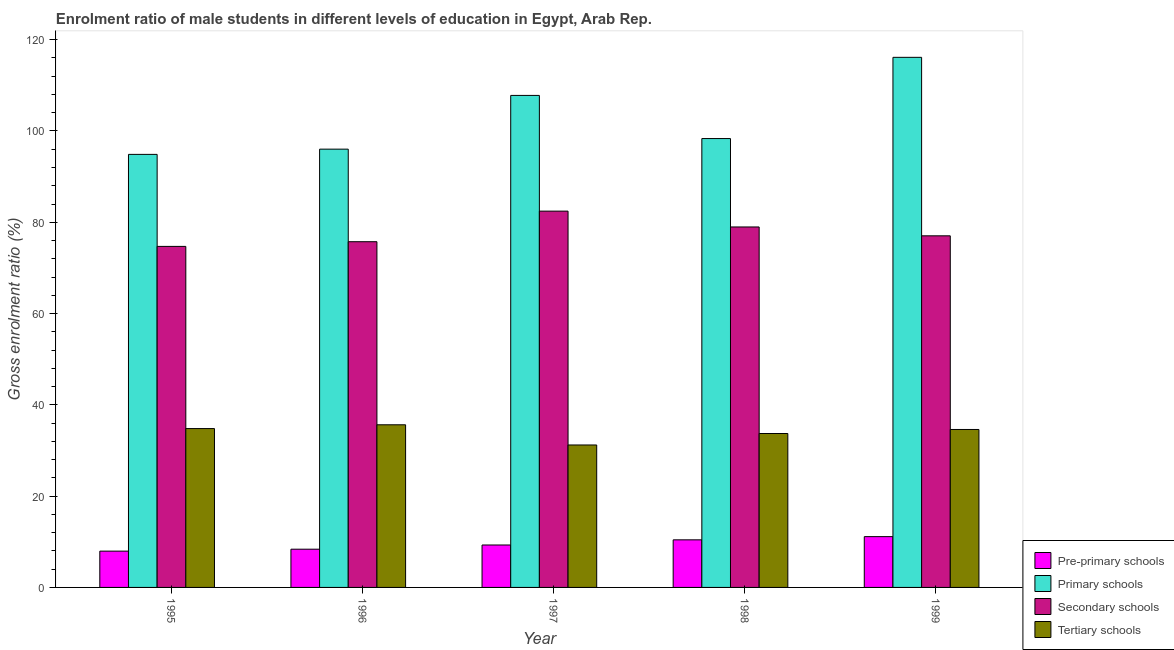How many groups of bars are there?
Provide a succinct answer. 5. Are the number of bars on each tick of the X-axis equal?
Provide a short and direct response. Yes. In how many cases, is the number of bars for a given year not equal to the number of legend labels?
Your answer should be very brief. 0. What is the gross enrolment ratio(female) in secondary schools in 1997?
Provide a succinct answer. 82.44. Across all years, what is the maximum gross enrolment ratio(female) in tertiary schools?
Make the answer very short. 35.63. Across all years, what is the minimum gross enrolment ratio(female) in primary schools?
Your answer should be very brief. 94.87. In which year was the gross enrolment ratio(female) in secondary schools minimum?
Give a very brief answer. 1995. What is the total gross enrolment ratio(female) in pre-primary schools in the graph?
Make the answer very short. 47.18. What is the difference between the gross enrolment ratio(female) in secondary schools in 1995 and that in 1997?
Offer a terse response. -7.73. What is the difference between the gross enrolment ratio(female) in secondary schools in 1998 and the gross enrolment ratio(female) in tertiary schools in 1999?
Provide a short and direct response. 1.94. What is the average gross enrolment ratio(female) in pre-primary schools per year?
Your answer should be compact. 9.44. In the year 1997, what is the difference between the gross enrolment ratio(female) in primary schools and gross enrolment ratio(female) in tertiary schools?
Give a very brief answer. 0. What is the ratio of the gross enrolment ratio(female) in pre-primary schools in 1995 to that in 1998?
Ensure brevity in your answer.  0.76. What is the difference between the highest and the second highest gross enrolment ratio(female) in secondary schools?
Give a very brief answer. 3.47. What is the difference between the highest and the lowest gross enrolment ratio(female) in secondary schools?
Provide a succinct answer. 7.73. What does the 2nd bar from the left in 1997 represents?
Keep it short and to the point. Primary schools. What does the 4th bar from the right in 1999 represents?
Ensure brevity in your answer.  Pre-primary schools. Is it the case that in every year, the sum of the gross enrolment ratio(female) in pre-primary schools and gross enrolment ratio(female) in primary schools is greater than the gross enrolment ratio(female) in secondary schools?
Provide a short and direct response. Yes. What is the difference between two consecutive major ticks on the Y-axis?
Give a very brief answer. 20. Where does the legend appear in the graph?
Provide a short and direct response. Bottom right. What is the title of the graph?
Offer a very short reply. Enrolment ratio of male students in different levels of education in Egypt, Arab Rep. What is the Gross enrolment ratio (%) in Pre-primary schools in 1995?
Provide a short and direct response. 7.95. What is the Gross enrolment ratio (%) in Primary schools in 1995?
Provide a short and direct response. 94.87. What is the Gross enrolment ratio (%) in Secondary schools in 1995?
Make the answer very short. 74.72. What is the Gross enrolment ratio (%) in Tertiary schools in 1995?
Make the answer very short. 34.8. What is the Gross enrolment ratio (%) in Pre-primary schools in 1996?
Your answer should be compact. 8.38. What is the Gross enrolment ratio (%) of Primary schools in 1996?
Provide a succinct answer. 96.02. What is the Gross enrolment ratio (%) of Secondary schools in 1996?
Make the answer very short. 75.74. What is the Gross enrolment ratio (%) in Tertiary schools in 1996?
Ensure brevity in your answer.  35.63. What is the Gross enrolment ratio (%) of Pre-primary schools in 1997?
Your response must be concise. 9.3. What is the Gross enrolment ratio (%) of Primary schools in 1997?
Make the answer very short. 107.79. What is the Gross enrolment ratio (%) in Secondary schools in 1997?
Provide a succinct answer. 82.44. What is the Gross enrolment ratio (%) of Tertiary schools in 1997?
Keep it short and to the point. 31.21. What is the Gross enrolment ratio (%) of Pre-primary schools in 1998?
Ensure brevity in your answer.  10.43. What is the Gross enrolment ratio (%) of Primary schools in 1998?
Offer a terse response. 98.34. What is the Gross enrolment ratio (%) of Secondary schools in 1998?
Your answer should be very brief. 78.97. What is the Gross enrolment ratio (%) of Tertiary schools in 1998?
Ensure brevity in your answer.  33.72. What is the Gross enrolment ratio (%) of Pre-primary schools in 1999?
Ensure brevity in your answer.  11.13. What is the Gross enrolment ratio (%) of Primary schools in 1999?
Offer a terse response. 116.14. What is the Gross enrolment ratio (%) in Secondary schools in 1999?
Provide a succinct answer. 77.03. What is the Gross enrolment ratio (%) in Tertiary schools in 1999?
Give a very brief answer. 34.6. Across all years, what is the maximum Gross enrolment ratio (%) in Pre-primary schools?
Give a very brief answer. 11.13. Across all years, what is the maximum Gross enrolment ratio (%) in Primary schools?
Keep it short and to the point. 116.14. Across all years, what is the maximum Gross enrolment ratio (%) in Secondary schools?
Offer a terse response. 82.44. Across all years, what is the maximum Gross enrolment ratio (%) of Tertiary schools?
Give a very brief answer. 35.63. Across all years, what is the minimum Gross enrolment ratio (%) in Pre-primary schools?
Your answer should be very brief. 7.95. Across all years, what is the minimum Gross enrolment ratio (%) in Primary schools?
Keep it short and to the point. 94.87. Across all years, what is the minimum Gross enrolment ratio (%) in Secondary schools?
Your answer should be very brief. 74.72. Across all years, what is the minimum Gross enrolment ratio (%) of Tertiary schools?
Offer a very short reply. 31.21. What is the total Gross enrolment ratio (%) in Pre-primary schools in the graph?
Make the answer very short. 47.18. What is the total Gross enrolment ratio (%) of Primary schools in the graph?
Keep it short and to the point. 513.17. What is the total Gross enrolment ratio (%) in Secondary schools in the graph?
Ensure brevity in your answer.  388.91. What is the total Gross enrolment ratio (%) in Tertiary schools in the graph?
Make the answer very short. 169.97. What is the difference between the Gross enrolment ratio (%) of Pre-primary schools in 1995 and that in 1996?
Provide a short and direct response. -0.42. What is the difference between the Gross enrolment ratio (%) in Primary schools in 1995 and that in 1996?
Make the answer very short. -1.15. What is the difference between the Gross enrolment ratio (%) of Secondary schools in 1995 and that in 1996?
Provide a short and direct response. -1.03. What is the difference between the Gross enrolment ratio (%) in Tertiary schools in 1995 and that in 1996?
Ensure brevity in your answer.  -0.83. What is the difference between the Gross enrolment ratio (%) of Pre-primary schools in 1995 and that in 1997?
Your response must be concise. -1.34. What is the difference between the Gross enrolment ratio (%) of Primary schools in 1995 and that in 1997?
Ensure brevity in your answer.  -12.92. What is the difference between the Gross enrolment ratio (%) in Secondary schools in 1995 and that in 1997?
Provide a succinct answer. -7.73. What is the difference between the Gross enrolment ratio (%) in Tertiary schools in 1995 and that in 1997?
Your response must be concise. 3.59. What is the difference between the Gross enrolment ratio (%) in Pre-primary schools in 1995 and that in 1998?
Keep it short and to the point. -2.47. What is the difference between the Gross enrolment ratio (%) of Primary schools in 1995 and that in 1998?
Ensure brevity in your answer.  -3.47. What is the difference between the Gross enrolment ratio (%) of Secondary schools in 1995 and that in 1998?
Your answer should be very brief. -4.26. What is the difference between the Gross enrolment ratio (%) of Tertiary schools in 1995 and that in 1998?
Your answer should be very brief. 1.08. What is the difference between the Gross enrolment ratio (%) of Pre-primary schools in 1995 and that in 1999?
Your response must be concise. -3.18. What is the difference between the Gross enrolment ratio (%) of Primary schools in 1995 and that in 1999?
Your answer should be very brief. -21.26. What is the difference between the Gross enrolment ratio (%) of Secondary schools in 1995 and that in 1999?
Make the answer very short. -2.32. What is the difference between the Gross enrolment ratio (%) of Tertiary schools in 1995 and that in 1999?
Your response must be concise. 0.2. What is the difference between the Gross enrolment ratio (%) in Pre-primary schools in 1996 and that in 1997?
Ensure brevity in your answer.  -0.92. What is the difference between the Gross enrolment ratio (%) of Primary schools in 1996 and that in 1997?
Offer a very short reply. -11.77. What is the difference between the Gross enrolment ratio (%) in Secondary schools in 1996 and that in 1997?
Keep it short and to the point. -6.7. What is the difference between the Gross enrolment ratio (%) in Tertiary schools in 1996 and that in 1997?
Ensure brevity in your answer.  4.42. What is the difference between the Gross enrolment ratio (%) in Pre-primary schools in 1996 and that in 1998?
Your answer should be very brief. -2.05. What is the difference between the Gross enrolment ratio (%) of Primary schools in 1996 and that in 1998?
Your answer should be compact. -2.32. What is the difference between the Gross enrolment ratio (%) of Secondary schools in 1996 and that in 1998?
Offer a terse response. -3.23. What is the difference between the Gross enrolment ratio (%) in Tertiary schools in 1996 and that in 1998?
Your answer should be compact. 1.91. What is the difference between the Gross enrolment ratio (%) in Pre-primary schools in 1996 and that in 1999?
Give a very brief answer. -2.75. What is the difference between the Gross enrolment ratio (%) of Primary schools in 1996 and that in 1999?
Keep it short and to the point. -20.12. What is the difference between the Gross enrolment ratio (%) of Secondary schools in 1996 and that in 1999?
Offer a very short reply. -1.29. What is the difference between the Gross enrolment ratio (%) of Tertiary schools in 1996 and that in 1999?
Your answer should be very brief. 1.03. What is the difference between the Gross enrolment ratio (%) of Pre-primary schools in 1997 and that in 1998?
Give a very brief answer. -1.13. What is the difference between the Gross enrolment ratio (%) in Primary schools in 1997 and that in 1998?
Your answer should be compact. 9.45. What is the difference between the Gross enrolment ratio (%) of Secondary schools in 1997 and that in 1998?
Your answer should be very brief. 3.47. What is the difference between the Gross enrolment ratio (%) of Tertiary schools in 1997 and that in 1998?
Offer a terse response. -2.51. What is the difference between the Gross enrolment ratio (%) of Pre-primary schools in 1997 and that in 1999?
Your answer should be compact. -1.83. What is the difference between the Gross enrolment ratio (%) of Primary schools in 1997 and that in 1999?
Offer a terse response. -8.34. What is the difference between the Gross enrolment ratio (%) of Secondary schools in 1997 and that in 1999?
Offer a terse response. 5.41. What is the difference between the Gross enrolment ratio (%) in Tertiary schools in 1997 and that in 1999?
Provide a succinct answer. -3.39. What is the difference between the Gross enrolment ratio (%) in Pre-primary schools in 1998 and that in 1999?
Provide a succinct answer. -0.7. What is the difference between the Gross enrolment ratio (%) of Primary schools in 1998 and that in 1999?
Offer a terse response. -17.8. What is the difference between the Gross enrolment ratio (%) in Secondary schools in 1998 and that in 1999?
Your response must be concise. 1.94. What is the difference between the Gross enrolment ratio (%) in Tertiary schools in 1998 and that in 1999?
Make the answer very short. -0.88. What is the difference between the Gross enrolment ratio (%) in Pre-primary schools in 1995 and the Gross enrolment ratio (%) in Primary schools in 1996?
Your answer should be very brief. -88.07. What is the difference between the Gross enrolment ratio (%) of Pre-primary schools in 1995 and the Gross enrolment ratio (%) of Secondary schools in 1996?
Offer a terse response. -67.79. What is the difference between the Gross enrolment ratio (%) in Pre-primary schools in 1995 and the Gross enrolment ratio (%) in Tertiary schools in 1996?
Give a very brief answer. -27.68. What is the difference between the Gross enrolment ratio (%) of Primary schools in 1995 and the Gross enrolment ratio (%) of Secondary schools in 1996?
Offer a terse response. 19.13. What is the difference between the Gross enrolment ratio (%) of Primary schools in 1995 and the Gross enrolment ratio (%) of Tertiary schools in 1996?
Provide a succinct answer. 59.24. What is the difference between the Gross enrolment ratio (%) in Secondary schools in 1995 and the Gross enrolment ratio (%) in Tertiary schools in 1996?
Ensure brevity in your answer.  39.08. What is the difference between the Gross enrolment ratio (%) in Pre-primary schools in 1995 and the Gross enrolment ratio (%) in Primary schools in 1997?
Make the answer very short. -99.84. What is the difference between the Gross enrolment ratio (%) in Pre-primary schools in 1995 and the Gross enrolment ratio (%) in Secondary schools in 1997?
Your response must be concise. -74.49. What is the difference between the Gross enrolment ratio (%) in Pre-primary schools in 1995 and the Gross enrolment ratio (%) in Tertiary schools in 1997?
Your answer should be compact. -23.26. What is the difference between the Gross enrolment ratio (%) in Primary schools in 1995 and the Gross enrolment ratio (%) in Secondary schools in 1997?
Give a very brief answer. 12.43. What is the difference between the Gross enrolment ratio (%) in Primary schools in 1995 and the Gross enrolment ratio (%) in Tertiary schools in 1997?
Ensure brevity in your answer.  63.66. What is the difference between the Gross enrolment ratio (%) of Secondary schools in 1995 and the Gross enrolment ratio (%) of Tertiary schools in 1997?
Your response must be concise. 43.51. What is the difference between the Gross enrolment ratio (%) of Pre-primary schools in 1995 and the Gross enrolment ratio (%) of Primary schools in 1998?
Provide a succinct answer. -90.39. What is the difference between the Gross enrolment ratio (%) of Pre-primary schools in 1995 and the Gross enrolment ratio (%) of Secondary schools in 1998?
Offer a terse response. -71.02. What is the difference between the Gross enrolment ratio (%) in Pre-primary schools in 1995 and the Gross enrolment ratio (%) in Tertiary schools in 1998?
Your response must be concise. -25.77. What is the difference between the Gross enrolment ratio (%) in Primary schools in 1995 and the Gross enrolment ratio (%) in Secondary schools in 1998?
Your answer should be very brief. 15.9. What is the difference between the Gross enrolment ratio (%) in Primary schools in 1995 and the Gross enrolment ratio (%) in Tertiary schools in 1998?
Provide a short and direct response. 61.15. What is the difference between the Gross enrolment ratio (%) in Secondary schools in 1995 and the Gross enrolment ratio (%) in Tertiary schools in 1998?
Provide a short and direct response. 40.99. What is the difference between the Gross enrolment ratio (%) of Pre-primary schools in 1995 and the Gross enrolment ratio (%) of Primary schools in 1999?
Keep it short and to the point. -108.18. What is the difference between the Gross enrolment ratio (%) of Pre-primary schools in 1995 and the Gross enrolment ratio (%) of Secondary schools in 1999?
Provide a short and direct response. -69.08. What is the difference between the Gross enrolment ratio (%) of Pre-primary schools in 1995 and the Gross enrolment ratio (%) of Tertiary schools in 1999?
Ensure brevity in your answer.  -26.65. What is the difference between the Gross enrolment ratio (%) in Primary schools in 1995 and the Gross enrolment ratio (%) in Secondary schools in 1999?
Provide a succinct answer. 17.84. What is the difference between the Gross enrolment ratio (%) of Primary schools in 1995 and the Gross enrolment ratio (%) of Tertiary schools in 1999?
Your answer should be very brief. 60.27. What is the difference between the Gross enrolment ratio (%) in Secondary schools in 1995 and the Gross enrolment ratio (%) in Tertiary schools in 1999?
Your answer should be compact. 40.11. What is the difference between the Gross enrolment ratio (%) of Pre-primary schools in 1996 and the Gross enrolment ratio (%) of Primary schools in 1997?
Keep it short and to the point. -99.42. What is the difference between the Gross enrolment ratio (%) of Pre-primary schools in 1996 and the Gross enrolment ratio (%) of Secondary schools in 1997?
Offer a very short reply. -74.07. What is the difference between the Gross enrolment ratio (%) of Pre-primary schools in 1996 and the Gross enrolment ratio (%) of Tertiary schools in 1997?
Offer a very short reply. -22.83. What is the difference between the Gross enrolment ratio (%) of Primary schools in 1996 and the Gross enrolment ratio (%) of Secondary schools in 1997?
Provide a succinct answer. 13.58. What is the difference between the Gross enrolment ratio (%) in Primary schools in 1996 and the Gross enrolment ratio (%) in Tertiary schools in 1997?
Make the answer very short. 64.81. What is the difference between the Gross enrolment ratio (%) in Secondary schools in 1996 and the Gross enrolment ratio (%) in Tertiary schools in 1997?
Provide a succinct answer. 44.53. What is the difference between the Gross enrolment ratio (%) of Pre-primary schools in 1996 and the Gross enrolment ratio (%) of Primary schools in 1998?
Give a very brief answer. -89.97. What is the difference between the Gross enrolment ratio (%) of Pre-primary schools in 1996 and the Gross enrolment ratio (%) of Secondary schools in 1998?
Give a very brief answer. -70.6. What is the difference between the Gross enrolment ratio (%) in Pre-primary schools in 1996 and the Gross enrolment ratio (%) in Tertiary schools in 1998?
Ensure brevity in your answer.  -25.35. What is the difference between the Gross enrolment ratio (%) in Primary schools in 1996 and the Gross enrolment ratio (%) in Secondary schools in 1998?
Keep it short and to the point. 17.05. What is the difference between the Gross enrolment ratio (%) in Primary schools in 1996 and the Gross enrolment ratio (%) in Tertiary schools in 1998?
Provide a short and direct response. 62.3. What is the difference between the Gross enrolment ratio (%) of Secondary schools in 1996 and the Gross enrolment ratio (%) of Tertiary schools in 1998?
Your answer should be very brief. 42.02. What is the difference between the Gross enrolment ratio (%) in Pre-primary schools in 1996 and the Gross enrolment ratio (%) in Primary schools in 1999?
Your response must be concise. -107.76. What is the difference between the Gross enrolment ratio (%) of Pre-primary schools in 1996 and the Gross enrolment ratio (%) of Secondary schools in 1999?
Provide a succinct answer. -68.66. What is the difference between the Gross enrolment ratio (%) of Pre-primary schools in 1996 and the Gross enrolment ratio (%) of Tertiary schools in 1999?
Offer a terse response. -26.23. What is the difference between the Gross enrolment ratio (%) of Primary schools in 1996 and the Gross enrolment ratio (%) of Secondary schools in 1999?
Ensure brevity in your answer.  18.99. What is the difference between the Gross enrolment ratio (%) of Primary schools in 1996 and the Gross enrolment ratio (%) of Tertiary schools in 1999?
Provide a succinct answer. 61.42. What is the difference between the Gross enrolment ratio (%) of Secondary schools in 1996 and the Gross enrolment ratio (%) of Tertiary schools in 1999?
Keep it short and to the point. 41.14. What is the difference between the Gross enrolment ratio (%) of Pre-primary schools in 1997 and the Gross enrolment ratio (%) of Primary schools in 1998?
Your response must be concise. -89.04. What is the difference between the Gross enrolment ratio (%) in Pre-primary schools in 1997 and the Gross enrolment ratio (%) in Secondary schools in 1998?
Make the answer very short. -69.67. What is the difference between the Gross enrolment ratio (%) in Pre-primary schools in 1997 and the Gross enrolment ratio (%) in Tertiary schools in 1998?
Provide a short and direct response. -24.42. What is the difference between the Gross enrolment ratio (%) of Primary schools in 1997 and the Gross enrolment ratio (%) of Secondary schools in 1998?
Offer a very short reply. 28.82. What is the difference between the Gross enrolment ratio (%) in Primary schools in 1997 and the Gross enrolment ratio (%) in Tertiary schools in 1998?
Make the answer very short. 74.07. What is the difference between the Gross enrolment ratio (%) of Secondary schools in 1997 and the Gross enrolment ratio (%) of Tertiary schools in 1998?
Ensure brevity in your answer.  48.72. What is the difference between the Gross enrolment ratio (%) in Pre-primary schools in 1997 and the Gross enrolment ratio (%) in Primary schools in 1999?
Make the answer very short. -106.84. What is the difference between the Gross enrolment ratio (%) of Pre-primary schools in 1997 and the Gross enrolment ratio (%) of Secondary schools in 1999?
Your answer should be compact. -67.74. What is the difference between the Gross enrolment ratio (%) in Pre-primary schools in 1997 and the Gross enrolment ratio (%) in Tertiary schools in 1999?
Provide a short and direct response. -25.31. What is the difference between the Gross enrolment ratio (%) of Primary schools in 1997 and the Gross enrolment ratio (%) of Secondary schools in 1999?
Give a very brief answer. 30.76. What is the difference between the Gross enrolment ratio (%) of Primary schools in 1997 and the Gross enrolment ratio (%) of Tertiary schools in 1999?
Your response must be concise. 73.19. What is the difference between the Gross enrolment ratio (%) of Secondary schools in 1997 and the Gross enrolment ratio (%) of Tertiary schools in 1999?
Provide a succinct answer. 47.84. What is the difference between the Gross enrolment ratio (%) of Pre-primary schools in 1998 and the Gross enrolment ratio (%) of Primary schools in 1999?
Ensure brevity in your answer.  -105.71. What is the difference between the Gross enrolment ratio (%) of Pre-primary schools in 1998 and the Gross enrolment ratio (%) of Secondary schools in 1999?
Provide a succinct answer. -66.61. What is the difference between the Gross enrolment ratio (%) of Pre-primary schools in 1998 and the Gross enrolment ratio (%) of Tertiary schools in 1999?
Provide a succinct answer. -24.18. What is the difference between the Gross enrolment ratio (%) in Primary schools in 1998 and the Gross enrolment ratio (%) in Secondary schools in 1999?
Ensure brevity in your answer.  21.31. What is the difference between the Gross enrolment ratio (%) in Primary schools in 1998 and the Gross enrolment ratio (%) in Tertiary schools in 1999?
Ensure brevity in your answer.  63.74. What is the difference between the Gross enrolment ratio (%) in Secondary schools in 1998 and the Gross enrolment ratio (%) in Tertiary schools in 1999?
Your answer should be very brief. 44.37. What is the average Gross enrolment ratio (%) in Pre-primary schools per year?
Your answer should be very brief. 9.44. What is the average Gross enrolment ratio (%) of Primary schools per year?
Offer a very short reply. 102.63. What is the average Gross enrolment ratio (%) in Secondary schools per year?
Your answer should be very brief. 77.78. What is the average Gross enrolment ratio (%) of Tertiary schools per year?
Offer a terse response. 33.99. In the year 1995, what is the difference between the Gross enrolment ratio (%) of Pre-primary schools and Gross enrolment ratio (%) of Primary schools?
Give a very brief answer. -86.92. In the year 1995, what is the difference between the Gross enrolment ratio (%) in Pre-primary schools and Gross enrolment ratio (%) in Secondary schools?
Offer a terse response. -66.76. In the year 1995, what is the difference between the Gross enrolment ratio (%) of Pre-primary schools and Gross enrolment ratio (%) of Tertiary schools?
Offer a terse response. -26.85. In the year 1995, what is the difference between the Gross enrolment ratio (%) of Primary schools and Gross enrolment ratio (%) of Secondary schools?
Ensure brevity in your answer.  20.16. In the year 1995, what is the difference between the Gross enrolment ratio (%) of Primary schools and Gross enrolment ratio (%) of Tertiary schools?
Your answer should be compact. 60.07. In the year 1995, what is the difference between the Gross enrolment ratio (%) in Secondary schools and Gross enrolment ratio (%) in Tertiary schools?
Keep it short and to the point. 39.91. In the year 1996, what is the difference between the Gross enrolment ratio (%) in Pre-primary schools and Gross enrolment ratio (%) in Primary schools?
Make the answer very short. -87.65. In the year 1996, what is the difference between the Gross enrolment ratio (%) of Pre-primary schools and Gross enrolment ratio (%) of Secondary schools?
Your answer should be very brief. -67.37. In the year 1996, what is the difference between the Gross enrolment ratio (%) in Pre-primary schools and Gross enrolment ratio (%) in Tertiary schools?
Provide a short and direct response. -27.26. In the year 1996, what is the difference between the Gross enrolment ratio (%) of Primary schools and Gross enrolment ratio (%) of Secondary schools?
Provide a succinct answer. 20.28. In the year 1996, what is the difference between the Gross enrolment ratio (%) in Primary schools and Gross enrolment ratio (%) in Tertiary schools?
Provide a succinct answer. 60.39. In the year 1996, what is the difference between the Gross enrolment ratio (%) in Secondary schools and Gross enrolment ratio (%) in Tertiary schools?
Your answer should be compact. 40.11. In the year 1997, what is the difference between the Gross enrolment ratio (%) in Pre-primary schools and Gross enrolment ratio (%) in Primary schools?
Offer a terse response. -98.5. In the year 1997, what is the difference between the Gross enrolment ratio (%) of Pre-primary schools and Gross enrolment ratio (%) of Secondary schools?
Give a very brief answer. -73.14. In the year 1997, what is the difference between the Gross enrolment ratio (%) in Pre-primary schools and Gross enrolment ratio (%) in Tertiary schools?
Your response must be concise. -21.91. In the year 1997, what is the difference between the Gross enrolment ratio (%) in Primary schools and Gross enrolment ratio (%) in Secondary schools?
Offer a terse response. 25.35. In the year 1997, what is the difference between the Gross enrolment ratio (%) in Primary schools and Gross enrolment ratio (%) in Tertiary schools?
Offer a very short reply. 76.58. In the year 1997, what is the difference between the Gross enrolment ratio (%) in Secondary schools and Gross enrolment ratio (%) in Tertiary schools?
Offer a terse response. 51.23. In the year 1998, what is the difference between the Gross enrolment ratio (%) in Pre-primary schools and Gross enrolment ratio (%) in Primary schools?
Keep it short and to the point. -87.91. In the year 1998, what is the difference between the Gross enrolment ratio (%) of Pre-primary schools and Gross enrolment ratio (%) of Secondary schools?
Provide a succinct answer. -68.55. In the year 1998, what is the difference between the Gross enrolment ratio (%) in Pre-primary schools and Gross enrolment ratio (%) in Tertiary schools?
Make the answer very short. -23.3. In the year 1998, what is the difference between the Gross enrolment ratio (%) of Primary schools and Gross enrolment ratio (%) of Secondary schools?
Keep it short and to the point. 19.37. In the year 1998, what is the difference between the Gross enrolment ratio (%) of Primary schools and Gross enrolment ratio (%) of Tertiary schools?
Provide a succinct answer. 64.62. In the year 1998, what is the difference between the Gross enrolment ratio (%) in Secondary schools and Gross enrolment ratio (%) in Tertiary schools?
Provide a short and direct response. 45.25. In the year 1999, what is the difference between the Gross enrolment ratio (%) in Pre-primary schools and Gross enrolment ratio (%) in Primary schools?
Your response must be concise. -105.01. In the year 1999, what is the difference between the Gross enrolment ratio (%) in Pre-primary schools and Gross enrolment ratio (%) in Secondary schools?
Offer a very short reply. -65.9. In the year 1999, what is the difference between the Gross enrolment ratio (%) of Pre-primary schools and Gross enrolment ratio (%) of Tertiary schools?
Offer a very short reply. -23.47. In the year 1999, what is the difference between the Gross enrolment ratio (%) in Primary schools and Gross enrolment ratio (%) in Secondary schools?
Provide a succinct answer. 39.1. In the year 1999, what is the difference between the Gross enrolment ratio (%) in Primary schools and Gross enrolment ratio (%) in Tertiary schools?
Make the answer very short. 81.53. In the year 1999, what is the difference between the Gross enrolment ratio (%) of Secondary schools and Gross enrolment ratio (%) of Tertiary schools?
Your response must be concise. 42.43. What is the ratio of the Gross enrolment ratio (%) in Pre-primary schools in 1995 to that in 1996?
Make the answer very short. 0.95. What is the ratio of the Gross enrolment ratio (%) of Primary schools in 1995 to that in 1996?
Make the answer very short. 0.99. What is the ratio of the Gross enrolment ratio (%) of Secondary schools in 1995 to that in 1996?
Make the answer very short. 0.99. What is the ratio of the Gross enrolment ratio (%) in Tertiary schools in 1995 to that in 1996?
Your response must be concise. 0.98. What is the ratio of the Gross enrolment ratio (%) in Pre-primary schools in 1995 to that in 1997?
Your answer should be compact. 0.86. What is the ratio of the Gross enrolment ratio (%) in Primary schools in 1995 to that in 1997?
Your answer should be compact. 0.88. What is the ratio of the Gross enrolment ratio (%) in Secondary schools in 1995 to that in 1997?
Your answer should be compact. 0.91. What is the ratio of the Gross enrolment ratio (%) in Tertiary schools in 1995 to that in 1997?
Ensure brevity in your answer.  1.12. What is the ratio of the Gross enrolment ratio (%) in Pre-primary schools in 1995 to that in 1998?
Your response must be concise. 0.76. What is the ratio of the Gross enrolment ratio (%) of Primary schools in 1995 to that in 1998?
Provide a succinct answer. 0.96. What is the ratio of the Gross enrolment ratio (%) in Secondary schools in 1995 to that in 1998?
Provide a short and direct response. 0.95. What is the ratio of the Gross enrolment ratio (%) in Tertiary schools in 1995 to that in 1998?
Offer a very short reply. 1.03. What is the ratio of the Gross enrolment ratio (%) in Pre-primary schools in 1995 to that in 1999?
Keep it short and to the point. 0.71. What is the ratio of the Gross enrolment ratio (%) in Primary schools in 1995 to that in 1999?
Provide a succinct answer. 0.82. What is the ratio of the Gross enrolment ratio (%) of Secondary schools in 1995 to that in 1999?
Provide a succinct answer. 0.97. What is the ratio of the Gross enrolment ratio (%) in Tertiary schools in 1995 to that in 1999?
Make the answer very short. 1.01. What is the ratio of the Gross enrolment ratio (%) in Pre-primary schools in 1996 to that in 1997?
Your answer should be very brief. 0.9. What is the ratio of the Gross enrolment ratio (%) of Primary schools in 1996 to that in 1997?
Your response must be concise. 0.89. What is the ratio of the Gross enrolment ratio (%) of Secondary schools in 1996 to that in 1997?
Keep it short and to the point. 0.92. What is the ratio of the Gross enrolment ratio (%) of Tertiary schools in 1996 to that in 1997?
Provide a short and direct response. 1.14. What is the ratio of the Gross enrolment ratio (%) in Pre-primary schools in 1996 to that in 1998?
Keep it short and to the point. 0.8. What is the ratio of the Gross enrolment ratio (%) of Primary schools in 1996 to that in 1998?
Your response must be concise. 0.98. What is the ratio of the Gross enrolment ratio (%) in Secondary schools in 1996 to that in 1998?
Keep it short and to the point. 0.96. What is the ratio of the Gross enrolment ratio (%) of Tertiary schools in 1996 to that in 1998?
Keep it short and to the point. 1.06. What is the ratio of the Gross enrolment ratio (%) in Pre-primary schools in 1996 to that in 1999?
Provide a short and direct response. 0.75. What is the ratio of the Gross enrolment ratio (%) of Primary schools in 1996 to that in 1999?
Ensure brevity in your answer.  0.83. What is the ratio of the Gross enrolment ratio (%) of Secondary schools in 1996 to that in 1999?
Provide a short and direct response. 0.98. What is the ratio of the Gross enrolment ratio (%) of Tertiary schools in 1996 to that in 1999?
Keep it short and to the point. 1.03. What is the ratio of the Gross enrolment ratio (%) of Pre-primary schools in 1997 to that in 1998?
Provide a succinct answer. 0.89. What is the ratio of the Gross enrolment ratio (%) of Primary schools in 1997 to that in 1998?
Offer a very short reply. 1.1. What is the ratio of the Gross enrolment ratio (%) of Secondary schools in 1997 to that in 1998?
Offer a very short reply. 1.04. What is the ratio of the Gross enrolment ratio (%) in Tertiary schools in 1997 to that in 1998?
Give a very brief answer. 0.93. What is the ratio of the Gross enrolment ratio (%) in Pre-primary schools in 1997 to that in 1999?
Offer a terse response. 0.84. What is the ratio of the Gross enrolment ratio (%) of Primary schools in 1997 to that in 1999?
Your response must be concise. 0.93. What is the ratio of the Gross enrolment ratio (%) in Secondary schools in 1997 to that in 1999?
Provide a succinct answer. 1.07. What is the ratio of the Gross enrolment ratio (%) in Tertiary schools in 1997 to that in 1999?
Your response must be concise. 0.9. What is the ratio of the Gross enrolment ratio (%) in Pre-primary schools in 1998 to that in 1999?
Your answer should be very brief. 0.94. What is the ratio of the Gross enrolment ratio (%) in Primary schools in 1998 to that in 1999?
Your response must be concise. 0.85. What is the ratio of the Gross enrolment ratio (%) of Secondary schools in 1998 to that in 1999?
Your answer should be compact. 1.03. What is the ratio of the Gross enrolment ratio (%) of Tertiary schools in 1998 to that in 1999?
Make the answer very short. 0.97. What is the difference between the highest and the second highest Gross enrolment ratio (%) of Pre-primary schools?
Your response must be concise. 0.7. What is the difference between the highest and the second highest Gross enrolment ratio (%) of Primary schools?
Your answer should be very brief. 8.34. What is the difference between the highest and the second highest Gross enrolment ratio (%) in Secondary schools?
Your answer should be compact. 3.47. What is the difference between the highest and the second highest Gross enrolment ratio (%) in Tertiary schools?
Give a very brief answer. 0.83. What is the difference between the highest and the lowest Gross enrolment ratio (%) in Pre-primary schools?
Your response must be concise. 3.18. What is the difference between the highest and the lowest Gross enrolment ratio (%) in Primary schools?
Make the answer very short. 21.26. What is the difference between the highest and the lowest Gross enrolment ratio (%) in Secondary schools?
Make the answer very short. 7.73. What is the difference between the highest and the lowest Gross enrolment ratio (%) in Tertiary schools?
Ensure brevity in your answer.  4.42. 